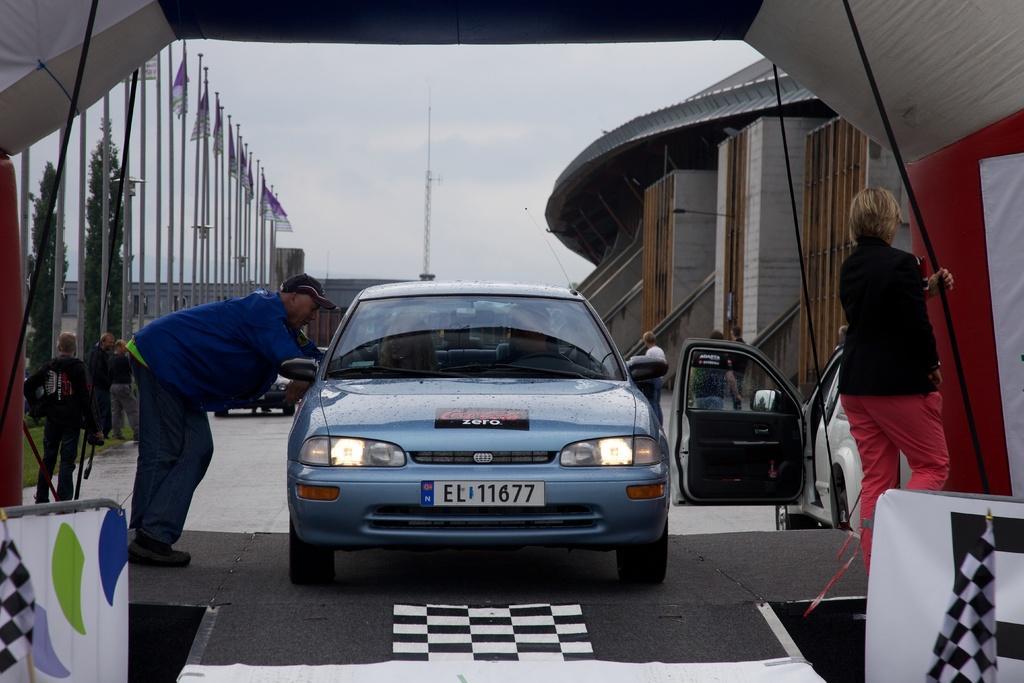Could you give a brief overview of what you see in this image? In this image I can see the vehicles on the road. I can see some people. On the left side I can see the flags and the trees. On the right side, I can see the buildings. At the top I can see a pole and clouds in the sky. 